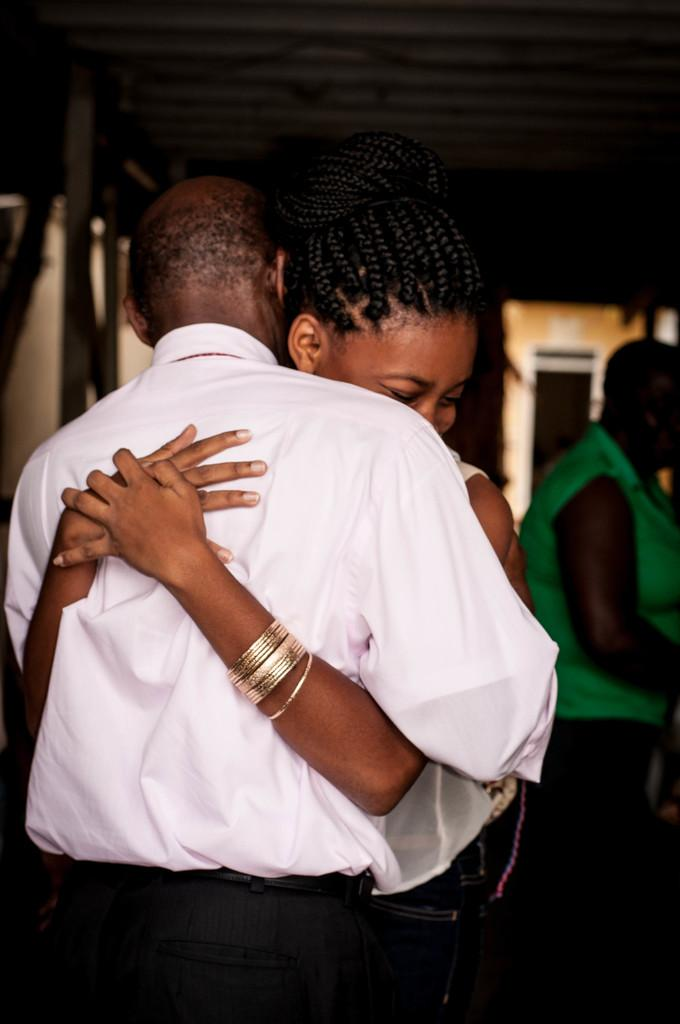What is the main subject of the image? The main subject of the image is a man and a woman. Where are the man and woman located in the image? The man and woman are in the center of the image. What is visible in the background of the image? There is a wall and a person in the background of the image. Can you see any fog in the image? There is no fog visible in the image. What type of train can be seen passing by in the image? There is no train present in the image. 